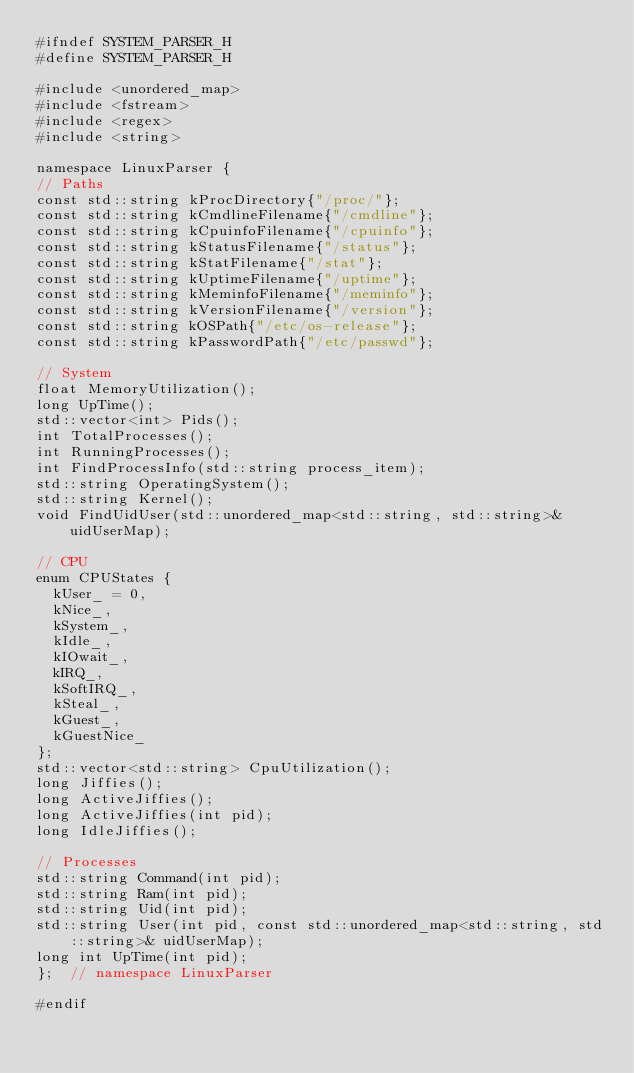<code> <loc_0><loc_0><loc_500><loc_500><_C_>#ifndef SYSTEM_PARSER_H
#define SYSTEM_PARSER_H

#include <unordered_map>
#include <fstream>
#include <regex>
#include <string>

namespace LinuxParser {
// Paths
const std::string kProcDirectory{"/proc/"};
const std::string kCmdlineFilename{"/cmdline"};
const std::string kCpuinfoFilename{"/cpuinfo"};
const std::string kStatusFilename{"/status"};
const std::string kStatFilename{"/stat"};
const std::string kUptimeFilename{"/uptime"};
const std::string kMeminfoFilename{"/meminfo"};
const std::string kVersionFilename{"/version"};
const std::string kOSPath{"/etc/os-release"};
const std::string kPasswordPath{"/etc/passwd"};

// System
float MemoryUtilization();
long UpTime();
std::vector<int> Pids();
int TotalProcesses();
int RunningProcesses();
int FindProcessInfo(std::string process_item);
std::string OperatingSystem();
std::string Kernel();
void FindUidUser(std::unordered_map<std::string, std::string>& uidUserMap);

// CPU
enum CPUStates {
  kUser_ = 0,
  kNice_,
  kSystem_,
  kIdle_,
  kIOwait_,
  kIRQ_,
  kSoftIRQ_,
  kSteal_,
  kGuest_,
  kGuestNice_
};
std::vector<std::string> CpuUtilization();
long Jiffies();
long ActiveJiffies();
long ActiveJiffies(int pid);
long IdleJiffies();

// Processes
std::string Command(int pid);
std::string Ram(int pid);
std::string Uid(int pid);
std::string User(int pid, const std::unordered_map<std::string, std::string>& uidUserMap);
long int UpTime(int pid);
};  // namespace LinuxParser

#endif</code> 